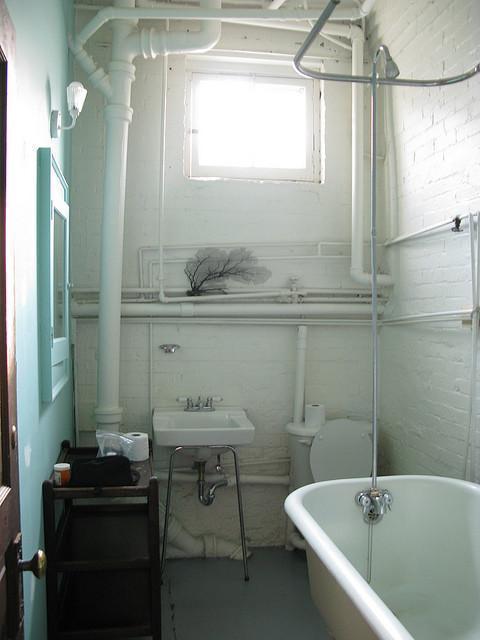How many sinks are there?
Give a very brief answer. 1. How many people are wearing yellow hats?
Give a very brief answer. 0. 